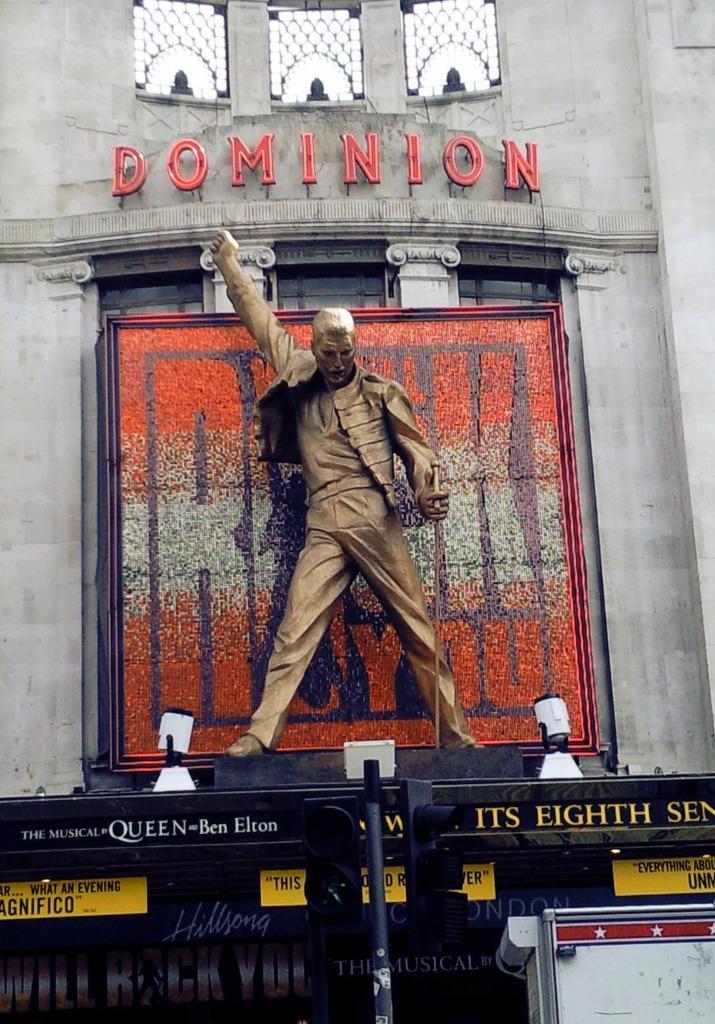How would you summarize this image in a sentence or two? In this picture there is a statue in the center of the image, which is golden in color and there are windows at the top side of the image, there is a stage at the bottom side of the image. 